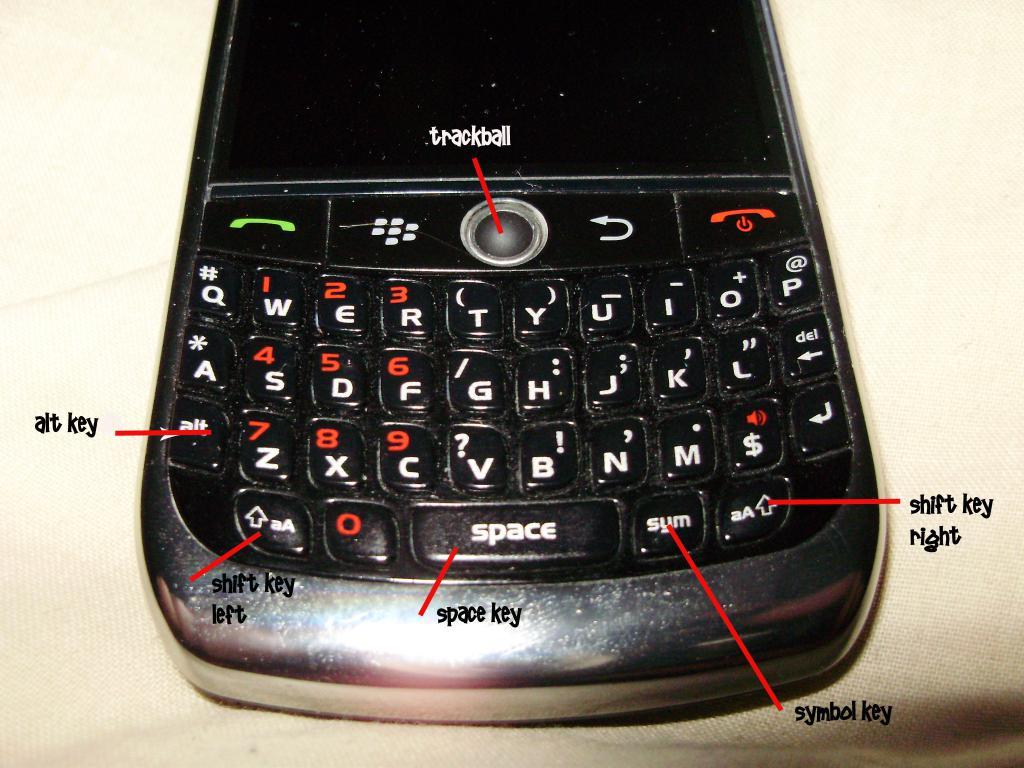What is the word on the largest key on the bottom row?
Your answer should be very brief. Space. What is the round thing in the middle of the phone?
Provide a succinct answer. Trackball. 